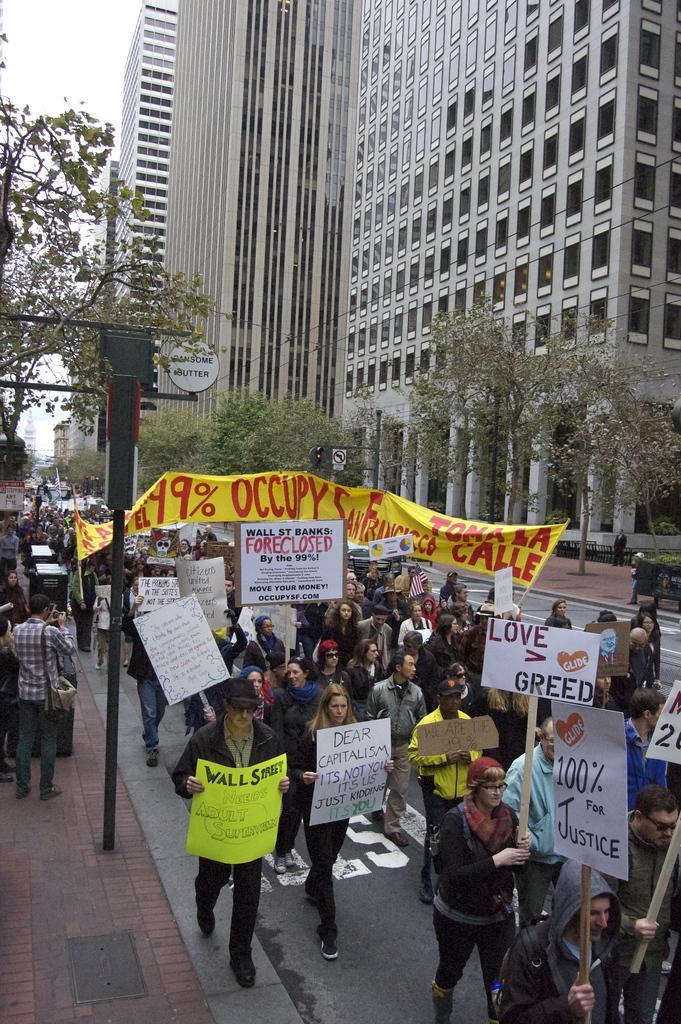Please provide a concise description of this image. This picture describes about group of people, few people holding placards, beside to them we can find a pole, few trees and sign boards, in the background we can see few buildings. 